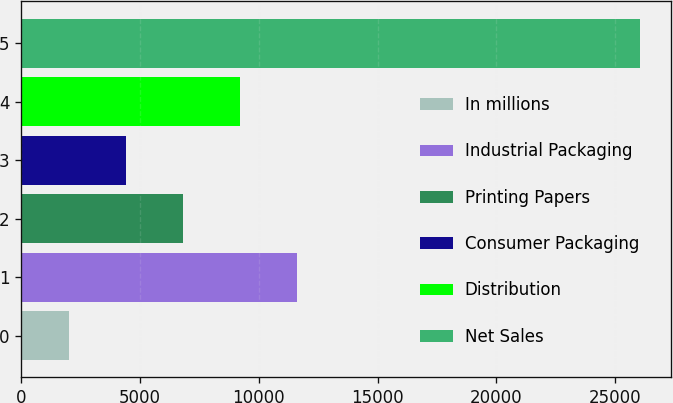<chart> <loc_0><loc_0><loc_500><loc_500><bar_chart><fcel>In millions<fcel>Industrial Packaging<fcel>Printing Papers<fcel>Consumer Packaging<fcel>Distribution<fcel>Net Sales<nl><fcel>2011<fcel>11620.2<fcel>6815.6<fcel>4413.3<fcel>9217.9<fcel>26034<nl></chart> 